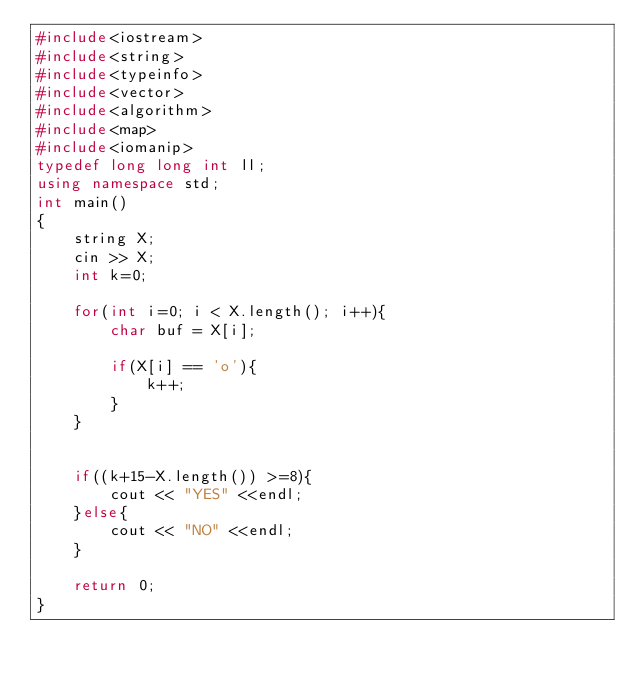Convert code to text. <code><loc_0><loc_0><loc_500><loc_500><_C++_>#include<iostream>
#include<string>
#include<typeinfo>
#include<vector>
#include<algorithm>
#include<map>
#include<iomanip>
typedef long long int ll;
using namespace std;
int main()
{
	string X;
	cin >> X;
	int k=0;

	for(int i=0; i < X.length(); i++){
		char buf = X[i];

		if(X[i] == 'o'){
			k++;
		}
	}


	if((k+15-X.length()) >=8){
		cout << "YES" <<endl;
	}else{
		cout << "NO" <<endl;
	}

	return 0;
}</code> 